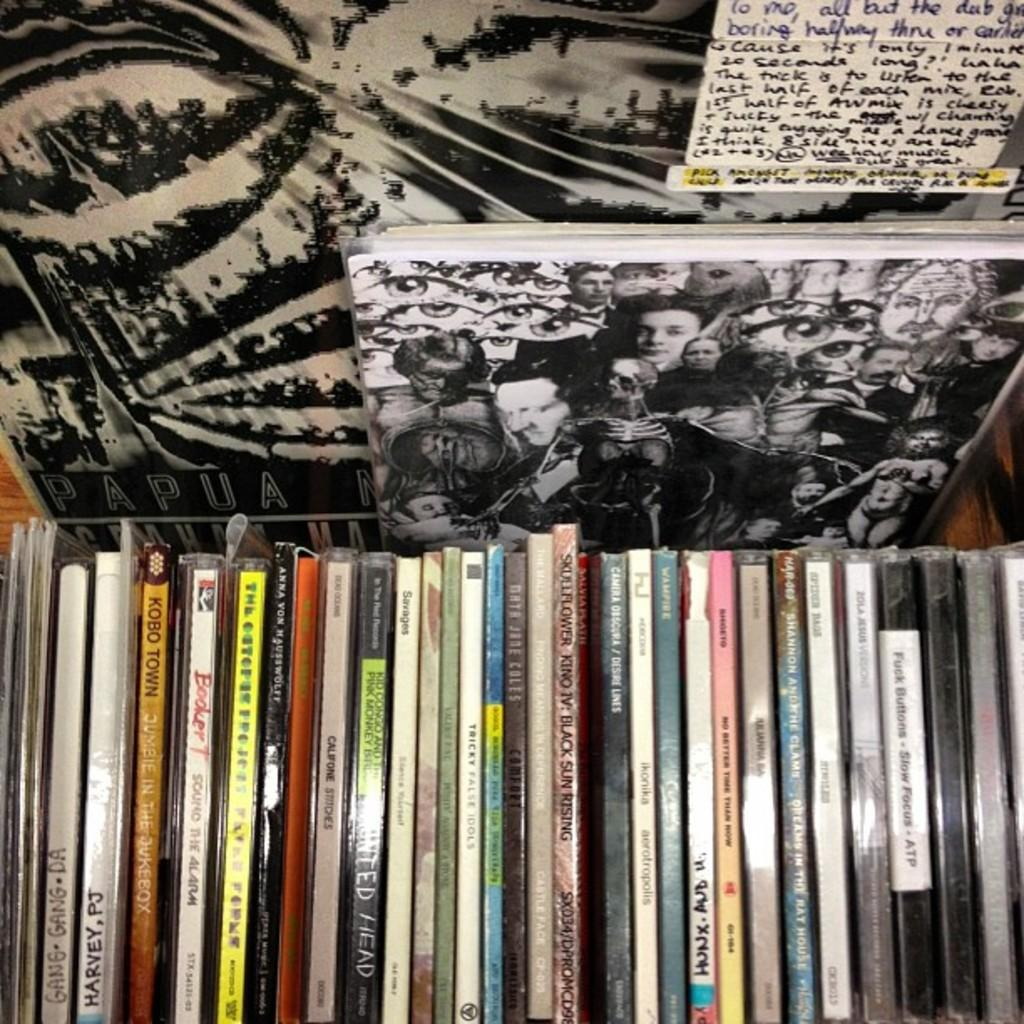<image>
Write a terse but informative summary of the picture. A PJ Harvey cd sits lined up with many other cds on a shelf. 